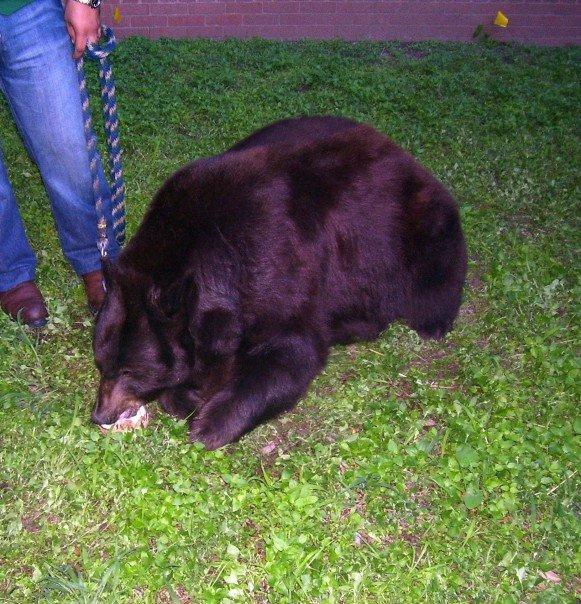Is the animal sitting or standing?
Write a very short answer. Sitting. Is anyone holding the leash?
Write a very short answer. Yes. How many flowers can be seen?
Short answer required. 1. What animal is on the leash?
Be succinct. Bear. Is the grass nicely cut?
Keep it brief. No. 